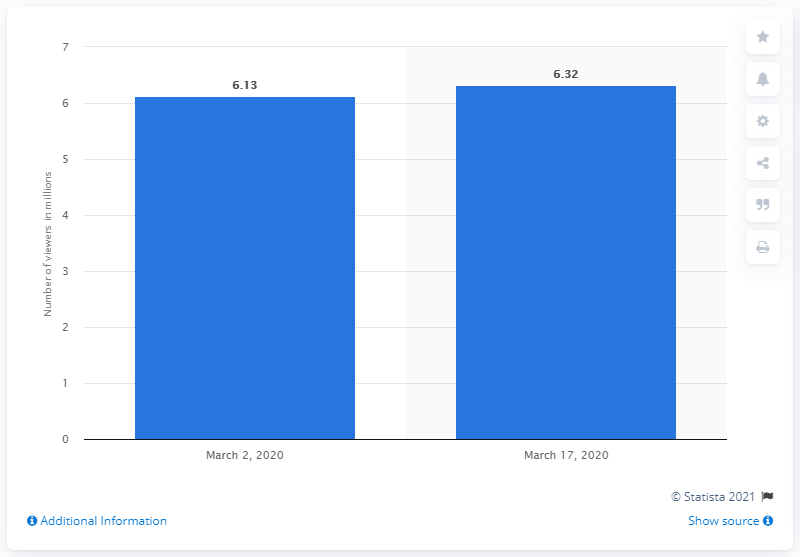Outline some significant characteristics in this image. According to a recent survey in the metropolitan region of Buenos Aires on March 2, 2020, a total of 6.13 people watched TV. On March 17, 2020, approximately 6.32 people watched television. 